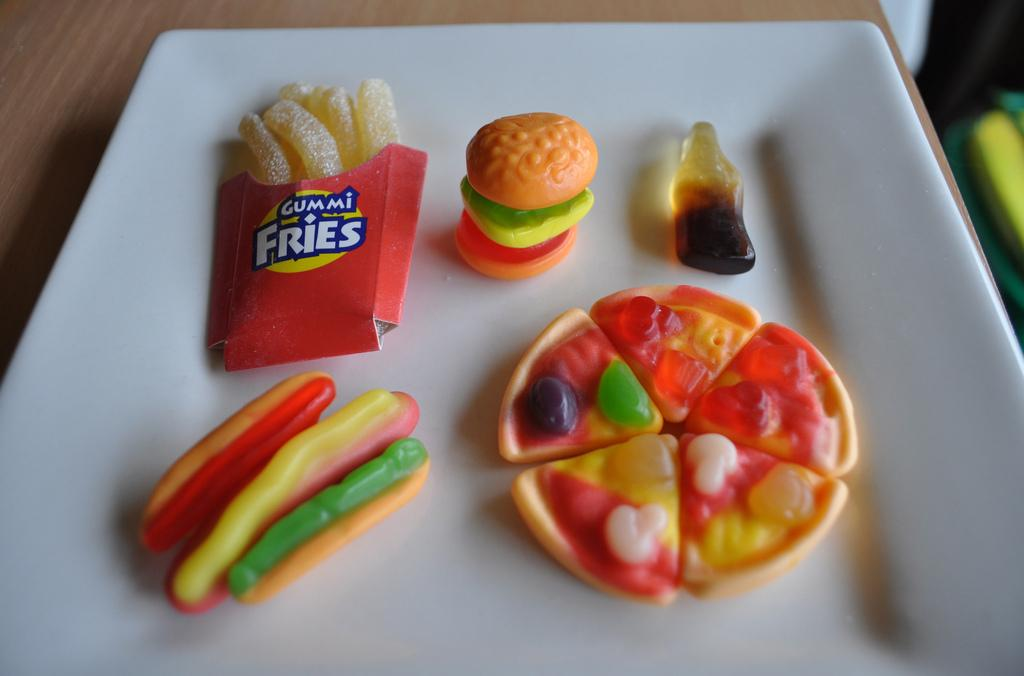What is present on the plate in the image? There are food items on the plate in the image. What color is the plate? The plate is white in color. What type of surface is beneath the plate? The surface beneath the plate appears to be wooden. What type of yarn is used to decorate the food items on the plate? There is no yarn present on the plate or used to decorate the food items in the image. 